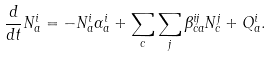<formula> <loc_0><loc_0><loc_500><loc_500>\frac { d } { d t } N _ { a } ^ { i } = - N _ { a } ^ { i } \alpha _ { a } ^ { i } + \sum _ { c } \sum _ { j } \beta _ { c a } ^ { i j } N _ { c } ^ { j } + Q _ { a } ^ { i } .</formula> 